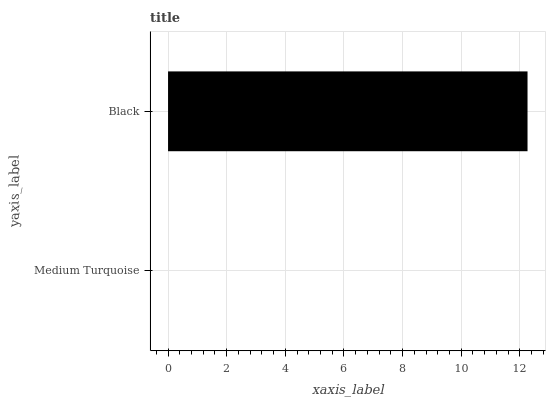Is Medium Turquoise the minimum?
Answer yes or no. Yes. Is Black the maximum?
Answer yes or no. Yes. Is Black the minimum?
Answer yes or no. No. Is Black greater than Medium Turquoise?
Answer yes or no. Yes. Is Medium Turquoise less than Black?
Answer yes or no. Yes. Is Medium Turquoise greater than Black?
Answer yes or no. No. Is Black less than Medium Turquoise?
Answer yes or no. No. Is Black the high median?
Answer yes or no. Yes. Is Medium Turquoise the low median?
Answer yes or no. Yes. Is Medium Turquoise the high median?
Answer yes or no. No. Is Black the low median?
Answer yes or no. No. 